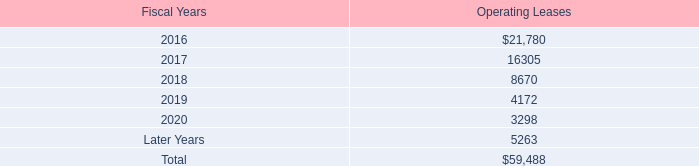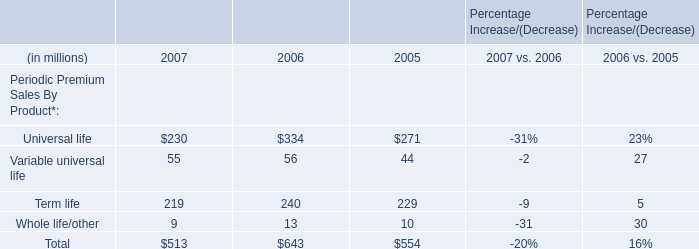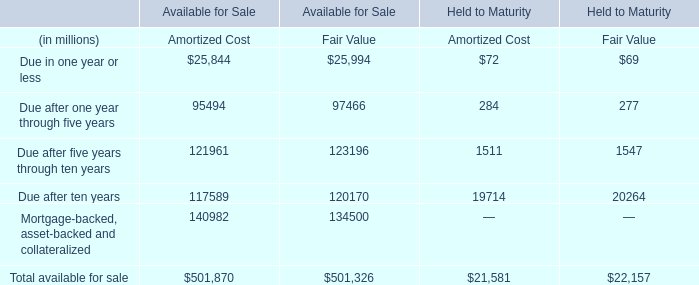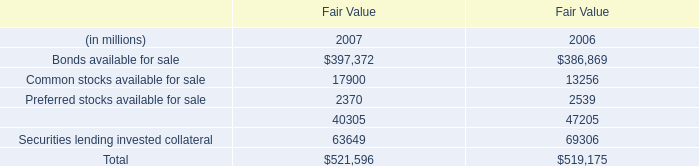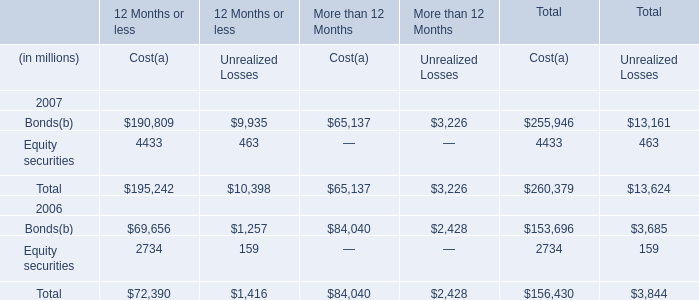What's the average of Cost and Unrealized Losses in 2007? (in million) 
Computations: ((260379 + 13624) / 2)
Answer: 137001.5. 